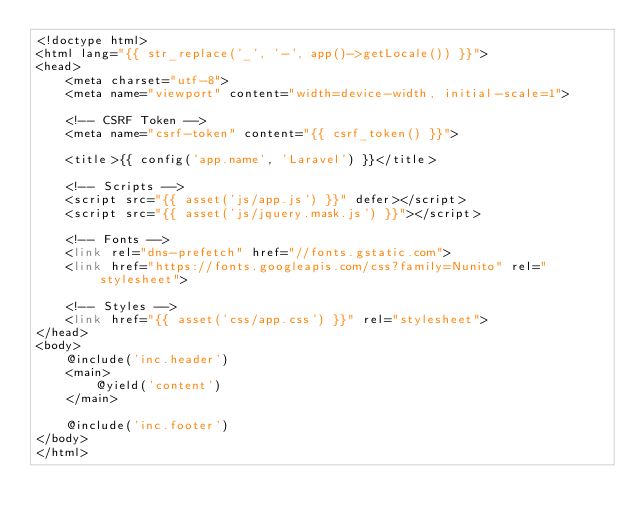<code> <loc_0><loc_0><loc_500><loc_500><_PHP_><!doctype html>
<html lang="{{ str_replace('_', '-', app()->getLocale()) }}">
<head>
    <meta charset="utf-8">
    <meta name="viewport" content="width=device-width, initial-scale=1">

    <!-- CSRF Token -->
    <meta name="csrf-token" content="{{ csrf_token() }}">

    <title>{{ config('app.name', 'Laravel') }}</title>

    <!-- Scripts -->
    <script src="{{ asset('js/app.js') }}" defer></script>
    <script src="{{ asset('js/jquery.mask.js') }}"></script>

    <!-- Fonts -->
    <link rel="dns-prefetch" href="//fonts.gstatic.com">
    <link href="https://fonts.googleapis.com/css?family=Nunito" rel="stylesheet">

    <!-- Styles -->
    <link href="{{ asset('css/app.css') }}" rel="stylesheet">
</head>
<body>
    @include('inc.header')
    <main>
        @yield('content')
    </main>
    
    @include('inc.footer')
</body>
</html>
</code> 